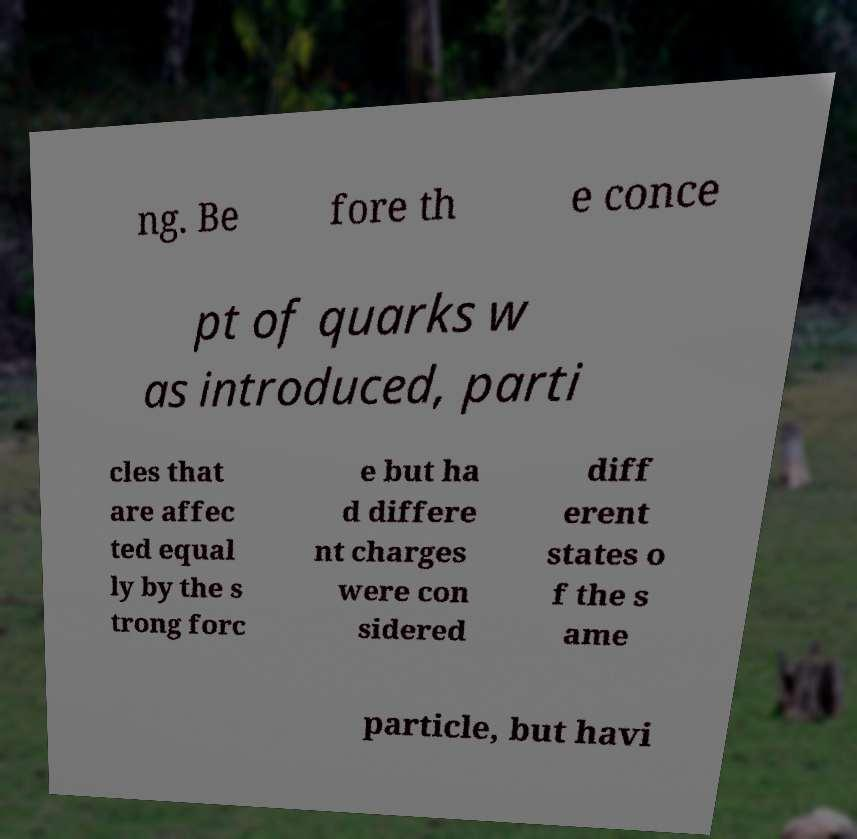What messages or text are displayed in this image? I need them in a readable, typed format. ng. Be fore th e conce pt of quarks w as introduced, parti cles that are affec ted equal ly by the s trong forc e but ha d differe nt charges were con sidered diff erent states o f the s ame particle, but havi 